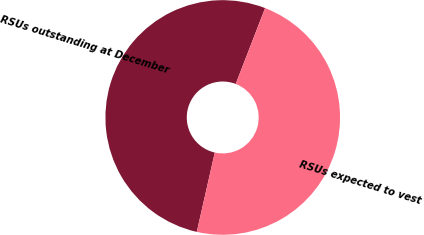Convert chart. <chart><loc_0><loc_0><loc_500><loc_500><pie_chart><fcel>RSUs outstanding at December<fcel>RSUs expected to vest<nl><fcel>52.33%<fcel>47.67%<nl></chart> 